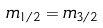<formula> <loc_0><loc_0><loc_500><loc_500>m _ { 1 / 2 } = m _ { 3 / 2 }</formula> 